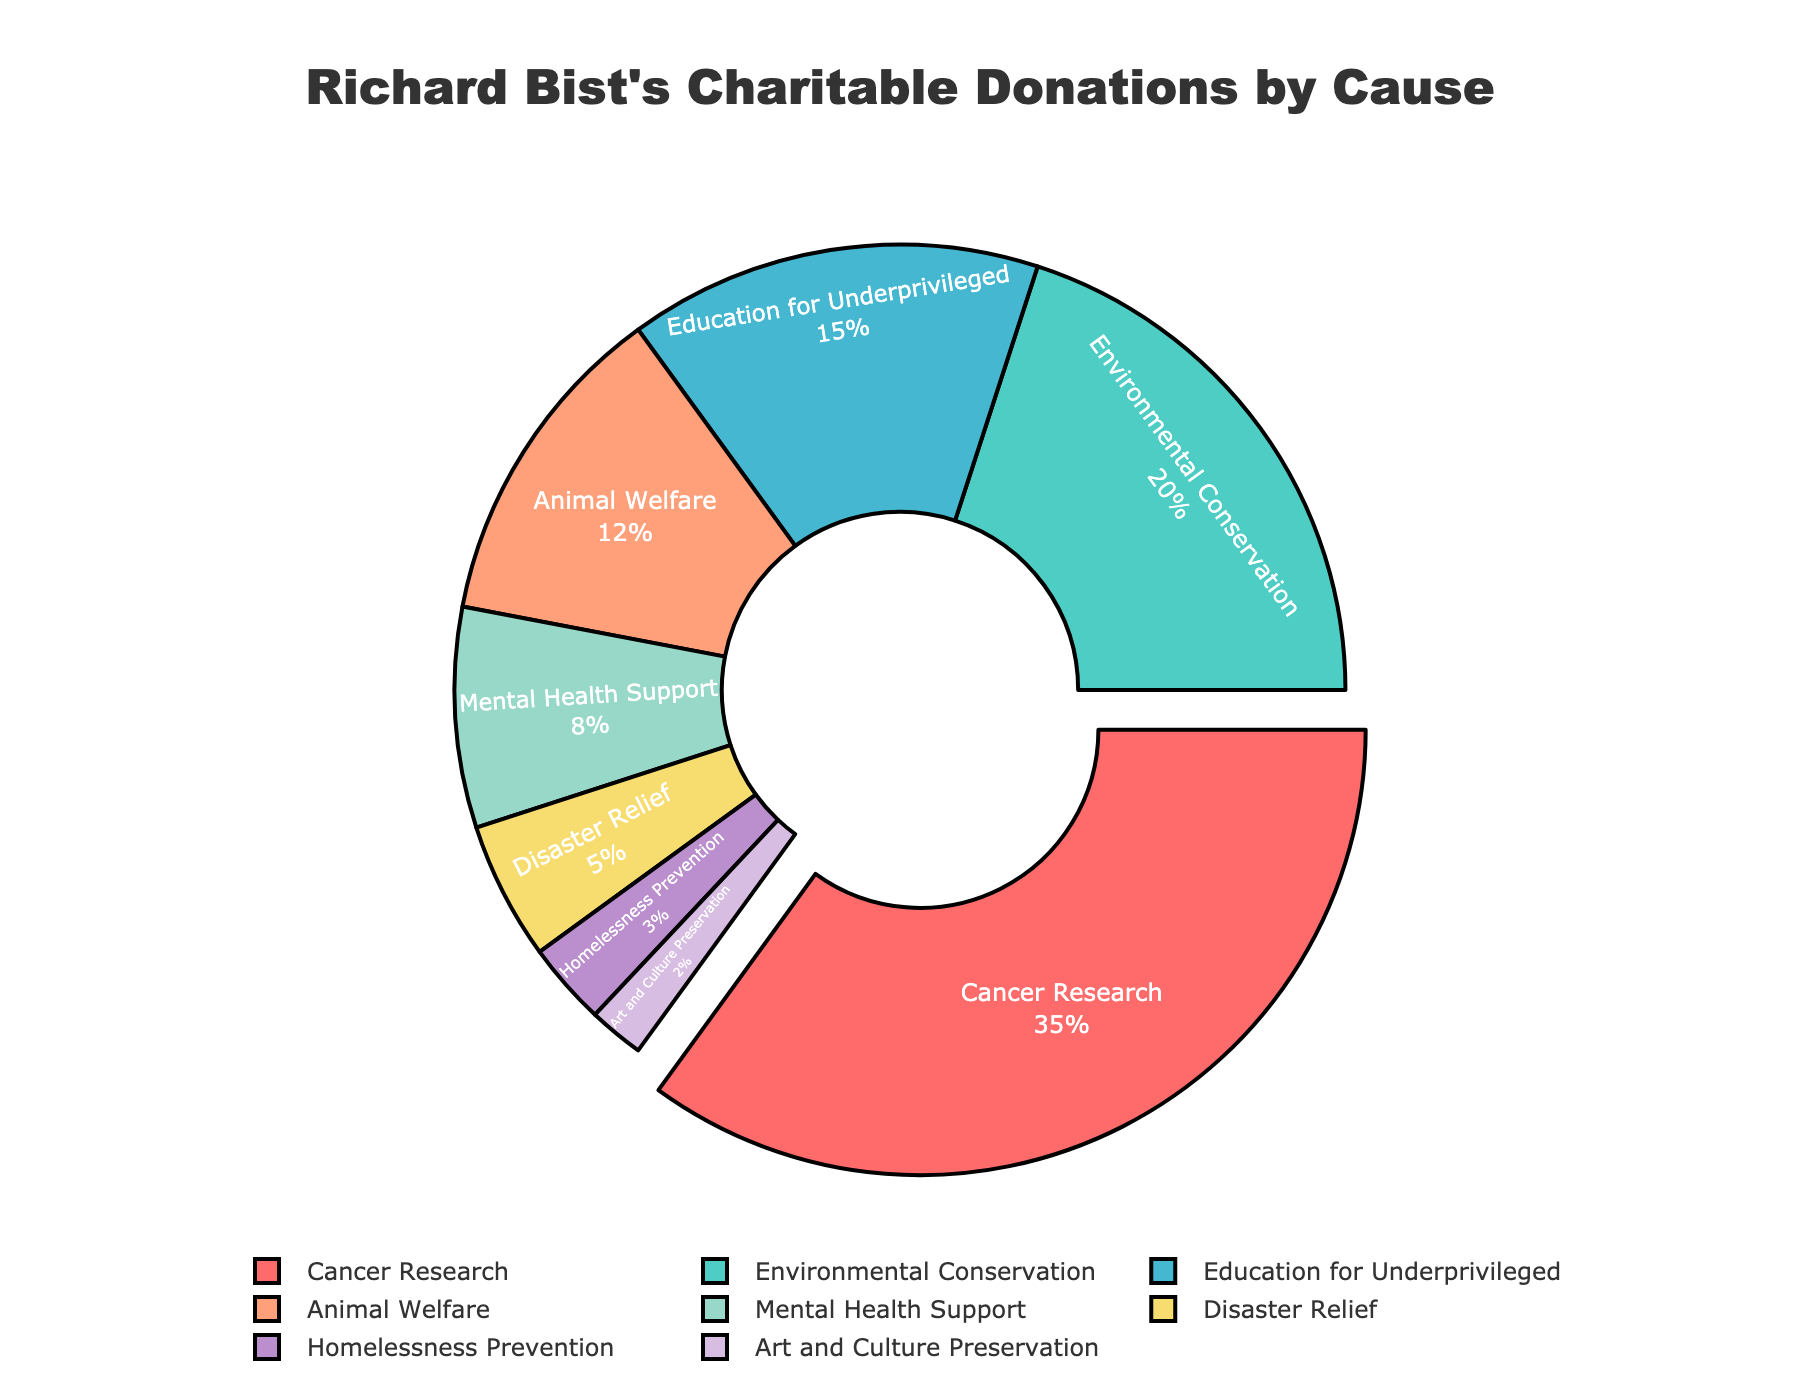What's the largest portion of Richard Bist's charitable donations? The largest portion can be identified by finding the sector with the highest percentage on the pie chart. The largest portion is the "Cancer Research" sector.
Answer: Cancer Research What cause receives the smallest percentage of donations? The smallest portion can be identified by locating the sector with the lowest percentage on the pie chart. The "Art and Culture Preservation" sector has the smallest percentage.
Answer: Art and Culture Preservation Which cause receives 20% of the donations? By examining the pie chart, the sector labeled "Environmental Conservation" accounts for 20% of the donations.
Answer: Environmental Conservation How much more does Cancer Research receive compared to Education for Underprivileged? Subtract the percentage of "Education for Underprivileged" from the percentage of "Cancer Research" to find the difference: 35% - 15% = 20%.
Answer: 20% What is the combined percentage of donations to Animal Welfare and Mental Health Support? Add the percentages of "Animal Welfare" and "Mental Health Support": 12% + 8% = 20%.
Answer: 20% Which causes receive less than 10% of the donations, and what is their combined percentage? Identify the sectors with less than 10%, which are "Mental Health Support", "Disaster Relief", "Homelessness Prevention", and "Art and Culture Preservation". Sum their percentages: 8% + 5% + 3% + 2% = 18%.
Answer: Mental Health Support, Disaster Relief, Homelessness Prevention, Art and Culture Preservation, 18% Among the causes, which one is more funded than Education for Underprivileged but less funded than Environmental Conservation? By comparing the percentages, "Animal Welfare" with 12% is more than 15% but less than 20%.
Answer: Animal Welfare What percentage of donations are allocated to Disaster Relief and Homelessness Prevention combined? Add the percentages of "Disaster Relief" and "Homelessness Prevention": 5% + 3% = 8%.
Answer: 8% Which cause closest to receiving half of what Cancer Research receives? Half of Cancer Research's 35% is 17.5%. "Environmental Conservation" with 20% is the closest cause.
Answer: Environmental Conservation How does the distribution of donations to Mental Health Support compare to that of Education for Underprivileged in terms of percentage points? Subtract the percentage of "Mental Health Support" from that of "Education for Underprivileged": 15% - 8% = 7%.
Answer: 7% 